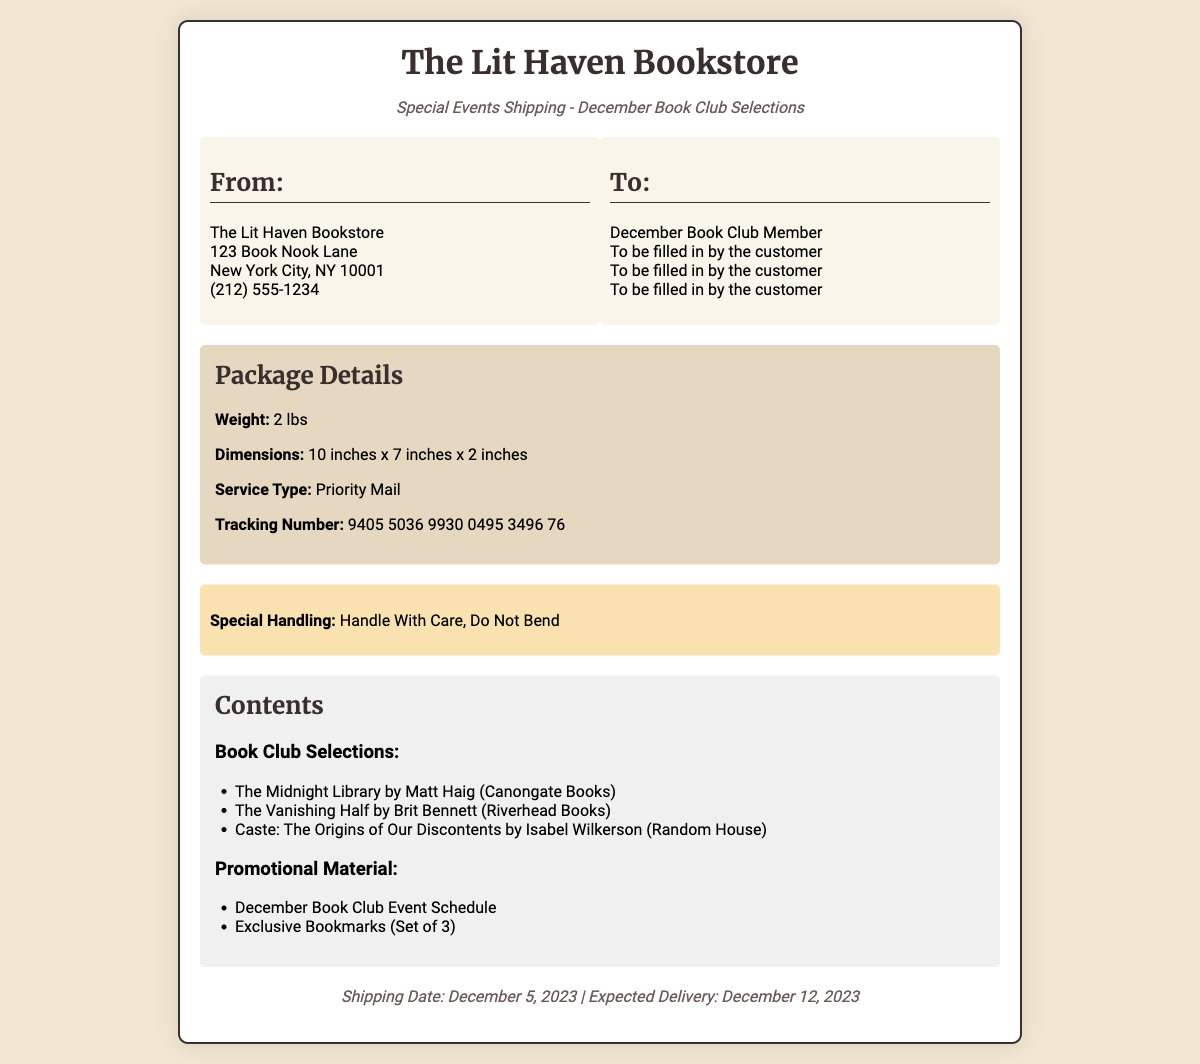What is the name of the bookstore? The name of the bookstore is mentioned in the header as The Lit Haven Bookstore.
Answer: The Lit Haven Bookstore What is the shipping weight? The document specifies the weight of the package in the Package Details section as 2 lbs.
Answer: 2 lbs When is the shipping date? The shipping date is provided in the footer section, which states that it is December 5, 2023.
Answer: December 5, 2023 What are the dimensions of the package? The dimensions of the package are listed in the Package Details section as 10 inches x 7 inches x 2 inches.
Answer: 10 inches x 7 inches x 2 inches What is the tracking number? The tracking number is outlined in the Package Details section as 9405 5036 9930 0495 3496 76.
Answer: 9405 5036 9930 0495 3496 76 What special handling instructions are provided? The special handling instructions are highlighted in the special handling section as Handle With Care, Do Not Bend.
Answer: Handle With Care, Do Not Bend How many books are listed as Book Club Selections? The Book Club Selections section lists three books, which can be counted.
Answer: 3 What promotional material is included with the shipment? The promotional materials are mentioned under Contents, which lists two items.
Answer: Exclusive Bookmarks (Set of 3) What is the expected delivery date? The expected delivery date is found in the footer section of the document, which states December 12, 2023.
Answer: December 12, 2023 Who is the recipient of the shipment? The recipient is specified in the "To" address section but is labeled as To be filled in by the customer.
Answer: To be filled in by the customer 